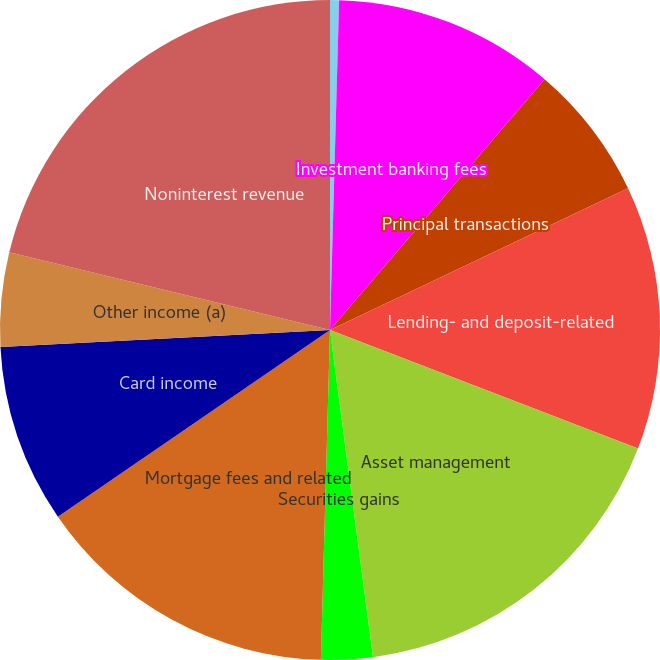Convert chart to OTSL. <chart><loc_0><loc_0><loc_500><loc_500><pie_chart><fcel>(in millions)<fcel>Investment banking fees<fcel>Principal transactions<fcel>Lending- and deposit-related<fcel>Asset management<fcel>Securities gains<fcel>Mortgage fees and related<fcel>Card income<fcel>Other income (a)<fcel>Noninterest revenue<nl><fcel>0.44%<fcel>10.83%<fcel>6.67%<fcel>12.91%<fcel>17.07%<fcel>2.52%<fcel>14.99%<fcel>8.75%<fcel>4.6%<fcel>21.22%<nl></chart> 